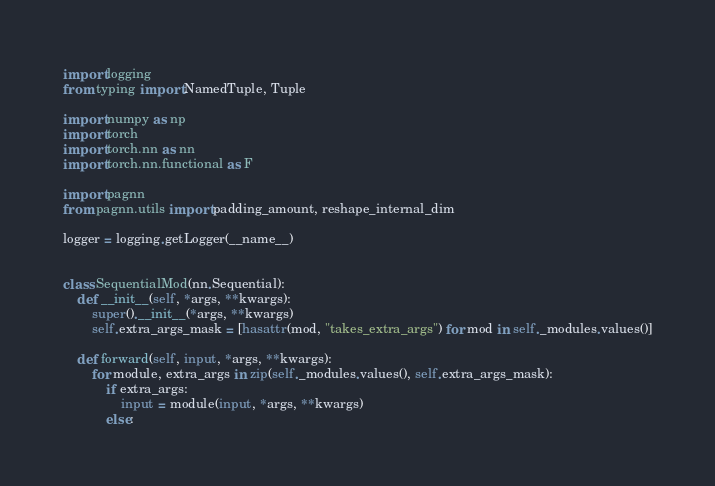<code> <loc_0><loc_0><loc_500><loc_500><_Python_>import logging
from typing import NamedTuple, Tuple

import numpy as np
import torch
import torch.nn as nn
import torch.nn.functional as F

import pagnn
from pagnn.utils import padding_amount, reshape_internal_dim

logger = logging.getLogger(__name__)


class SequentialMod(nn.Sequential):
    def __init__(self, *args, **kwargs):
        super().__init__(*args, **kwargs)
        self.extra_args_mask = [hasattr(mod, "takes_extra_args") for mod in self._modules.values()]

    def forward(self, input, *args, **kwargs):
        for module, extra_args in zip(self._modules.values(), self.extra_args_mask):
            if extra_args:
                input = module(input, *args, **kwargs)
            else:</code> 